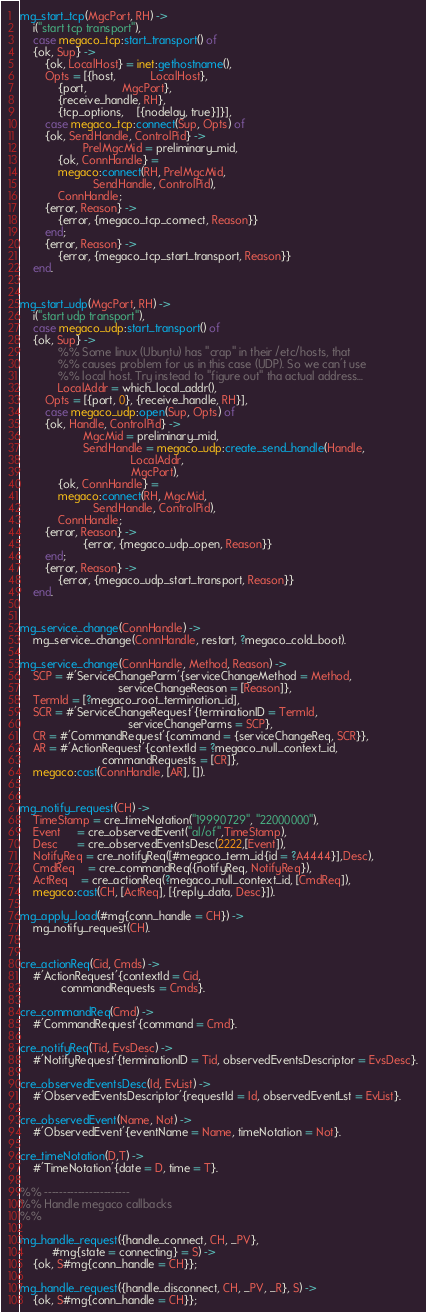<code> <loc_0><loc_0><loc_500><loc_500><_Erlang_>

mg_start_tcp(MgcPort, RH) ->
    i("start tcp transport"),
    case megaco_tcp:start_transport() of
	{ok, Sup} ->
	    {ok, LocalHost} = inet:gethostname(),
	    Opts = [{host,           LocalHost},
		    {port,           MgcPort}, 
		    {receive_handle, RH}, 
		    {tcp_options,    [{nodelay, true}]}],
	    case megaco_tcp:connect(Sup, Opts) of
		{ok, SendHandle, ControlPid} ->
                    PrelMgcMid = preliminary_mid,
		    {ok, ConnHandle} = 
			megaco:connect(RH, PrelMgcMid, 
				       SendHandle, ControlPid),
		    ConnHandle;
		{error, Reason} ->
		    {error, {megaco_tcp_connect, Reason}}
	    end;
        {error, Reason} ->
            {error, {megaco_tcp_start_transport, Reason}}
    end.


mg_start_udp(MgcPort, RH) ->
    i("start udp transport"),
    case megaco_udp:start_transport() of
	{ok, Sup} ->
            %% Some linux (Ubuntu) has "crap" in their /etc/hosts, that 
            %% causes problem for us in this case (UDP). So we can't use
            %% local host. Try instead to "figure out" tha actual address...
            LocalAddr = which_local_addr(),
	    Opts = [{port, 0}, {receive_handle, RH}],
	    case megaco_udp:open(Sup, Opts) of
		{ok, Handle, ControlPid} ->
                    MgcMid = preliminary_mid,
                    SendHandle = megaco_udp:create_send_handle(Handle, 
							       LocalAddr, 
							       MgcPort),
		    {ok, ConnHandle} = 
			megaco:connect(RH, MgcMid, 
				       SendHandle, ControlPid),
		    ConnHandle;
		{error, Reason} ->
                    {error, {megaco_udp_open, Reason}}
	    end;
        {error, Reason} ->
            {error, {megaco_udp_start_transport, Reason}}
    end.


mg_service_change(ConnHandle) ->
    mg_service_change(ConnHandle, restart, ?megaco_cold_boot).

mg_service_change(ConnHandle, Method, Reason) ->
    SCP = #'ServiceChangeParm'{serviceChangeMethod = Method,
                               serviceChangeReason = [Reason]},
    TermId = [?megaco_root_termination_id],
    SCR = #'ServiceChangeRequest'{terminationID = TermId,
                                  serviceChangeParms = SCP},
    CR = #'CommandRequest'{command = {serviceChangeReq, SCR}},
    AR = #'ActionRequest'{contextId = ?megaco_null_context_id,
                          commandRequests = [CR]},
    megaco:cast(ConnHandle, [AR], []).


mg_notify_request(CH) ->
    TimeStamp = cre_timeNotation("19990729", "22000000"),
    Event     = cre_observedEvent("al/of",TimeStamp),
    Desc      = cre_observedEventsDesc(2222,[Event]),
    NotifyReq = cre_notifyReq([#megaco_term_id{id = ?A4444}],Desc),
    CmdReq    = cre_commandReq({notifyReq, NotifyReq}),
    ActReq    = cre_actionReq(?megaco_null_context_id, [CmdReq]),
    megaco:cast(CH, [ActReq], [{reply_data, Desc}]).
    
mg_apply_load(#mg{conn_handle = CH}) ->
    mg_notify_request(CH).


cre_actionReq(Cid, Cmds) ->
    #'ActionRequest'{contextId = Cid,
		     commandRequests = Cmds}.

cre_commandReq(Cmd) ->
    #'CommandRequest'{command = Cmd}.

cre_notifyReq(Tid, EvsDesc) ->
    #'NotifyRequest'{terminationID = Tid, observedEventsDescriptor = EvsDesc}.

cre_observedEventsDesc(Id, EvList) ->
    #'ObservedEventsDescriptor'{requestId = Id, observedEventLst = EvList}.

cre_observedEvent(Name, Not) ->
    #'ObservedEvent'{eventName = Name, timeNotation = Not}.

cre_timeNotation(D,T) ->
    #'TimeNotation'{date = D, time = T}.

%% -----------------------
%% Handle megaco callbacks
%%

mg_handle_request({handle_connect, CH, _PV}, 
		  #mg{state = connecting} = S) ->
    {ok, S#mg{conn_handle = CH}};

mg_handle_request({handle_disconnect, CH, _PV, _R}, S) ->
    {ok, S#mg{conn_handle = CH}};
</code> 